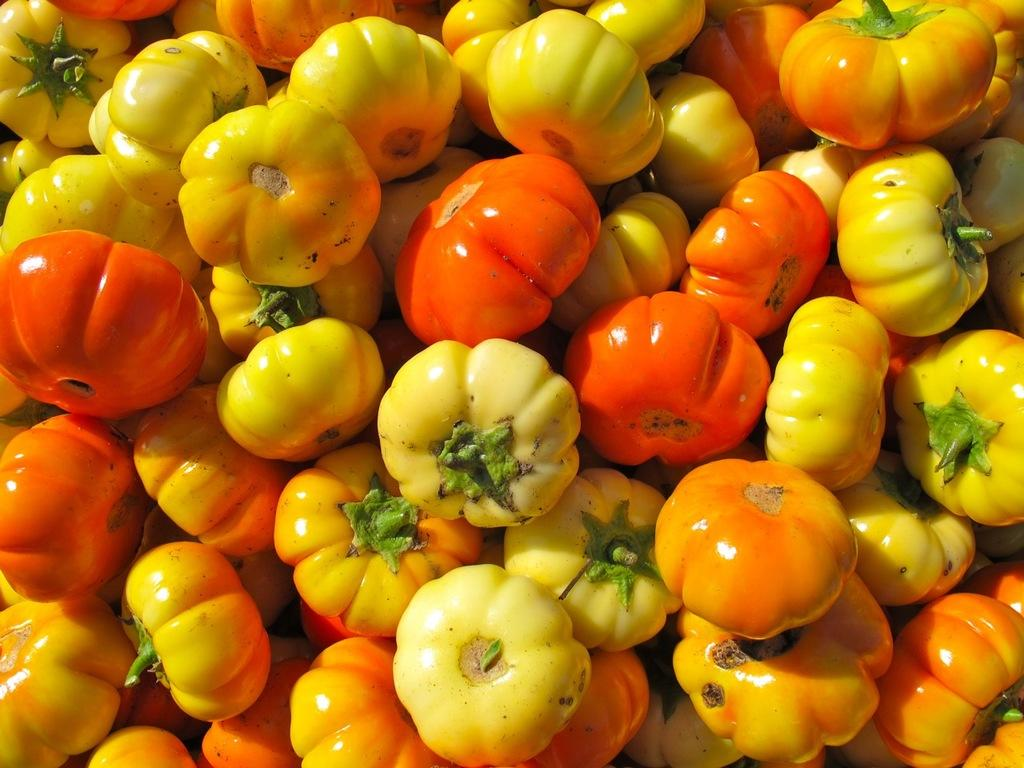What type of fruit is present in the image? There are tomatoes in the image. Can you describe the tomatoes in the image? The tomatoes are in different colors. What type of bait is used by the lawyer in the image? There is no lawyer or bait present in the image; it only features tomatoes in different colors. 